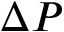Convert formula to latex. <formula><loc_0><loc_0><loc_500><loc_500>\Delta P</formula> 